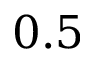<formula> <loc_0><loc_0><loc_500><loc_500>0 . 5</formula> 